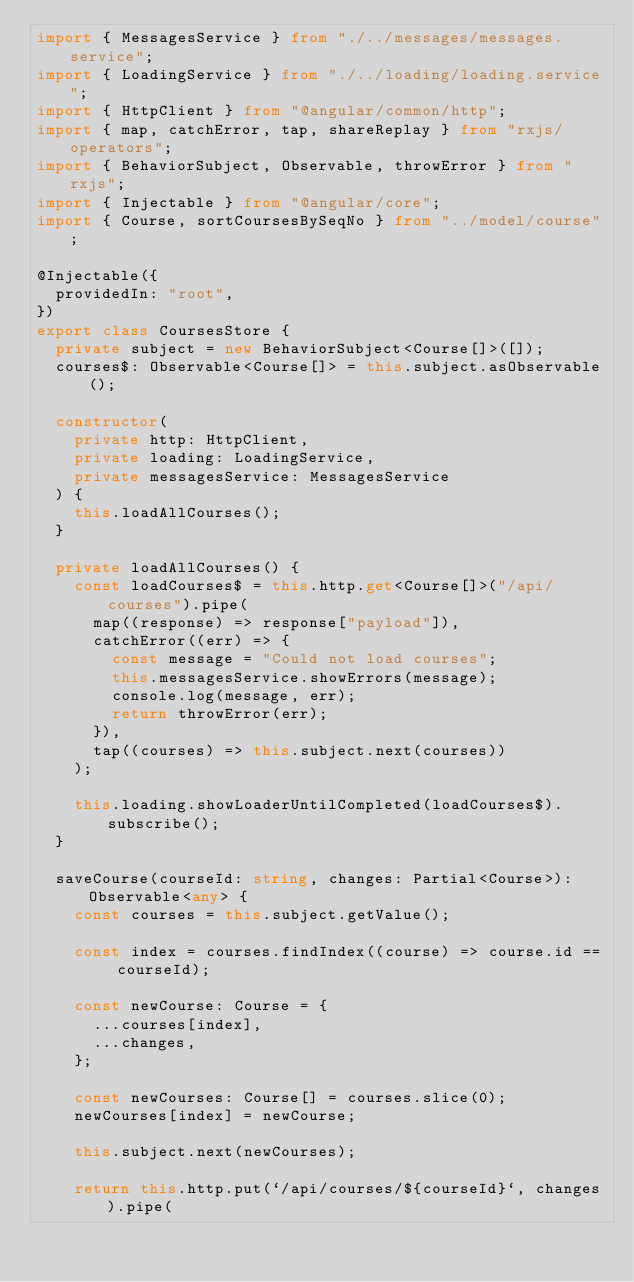Convert code to text. <code><loc_0><loc_0><loc_500><loc_500><_TypeScript_>import { MessagesService } from "./../messages/messages.service";
import { LoadingService } from "./../loading/loading.service";
import { HttpClient } from "@angular/common/http";
import { map, catchError, tap, shareReplay } from "rxjs/operators";
import { BehaviorSubject, Observable, throwError } from "rxjs";
import { Injectable } from "@angular/core";
import { Course, sortCoursesBySeqNo } from "../model/course";

@Injectable({
  providedIn: "root",
})
export class CoursesStore {
  private subject = new BehaviorSubject<Course[]>([]);
  courses$: Observable<Course[]> = this.subject.asObservable();

  constructor(
    private http: HttpClient,
    private loading: LoadingService,
    private messagesService: MessagesService
  ) {
    this.loadAllCourses();
  }

  private loadAllCourses() {
    const loadCourses$ = this.http.get<Course[]>("/api/courses").pipe(
      map((response) => response["payload"]),
      catchError((err) => {
        const message = "Could not load courses";
        this.messagesService.showErrors(message);
        console.log(message, err);
        return throwError(err);
      }),
      tap((courses) => this.subject.next(courses))
    );

    this.loading.showLoaderUntilCompleted(loadCourses$).subscribe();
  }

  saveCourse(courseId: string, changes: Partial<Course>): Observable<any> {
    const courses = this.subject.getValue();

    const index = courses.findIndex((course) => course.id == courseId);

    const newCourse: Course = {
      ...courses[index],
      ...changes,
    };

    const newCourses: Course[] = courses.slice(0);
    newCourses[index] = newCourse;

    this.subject.next(newCourses);

    return this.http.put(`/api/courses/${courseId}`, changes).pipe(</code> 